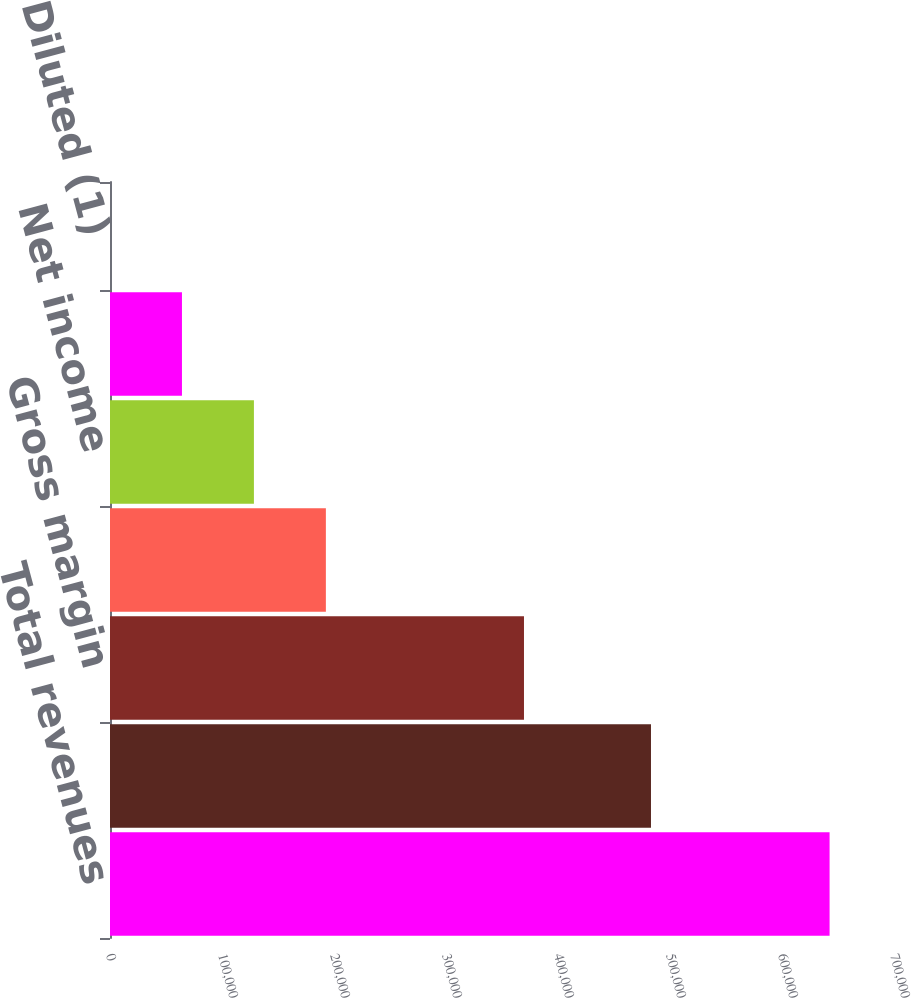<chart> <loc_0><loc_0><loc_500><loc_500><bar_chart><fcel>Total revenues<fcel>Total costs and operating<fcel>Gross margin<fcel>Income from operations<fcel>Net income<fcel>Basic (1)<fcel>Diluted (1)<nl><fcel>642482<fcel>483019<fcel>369627<fcel>192745<fcel>128497<fcel>64248.8<fcel>0.66<nl></chart> 